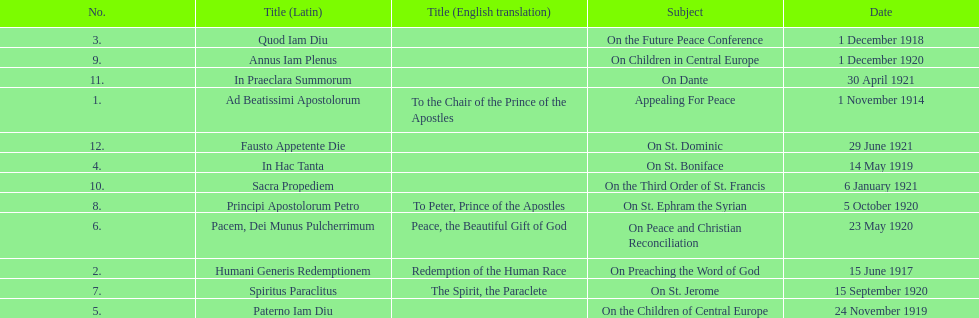What is the total number of encyclicals to take place in december? 2. 